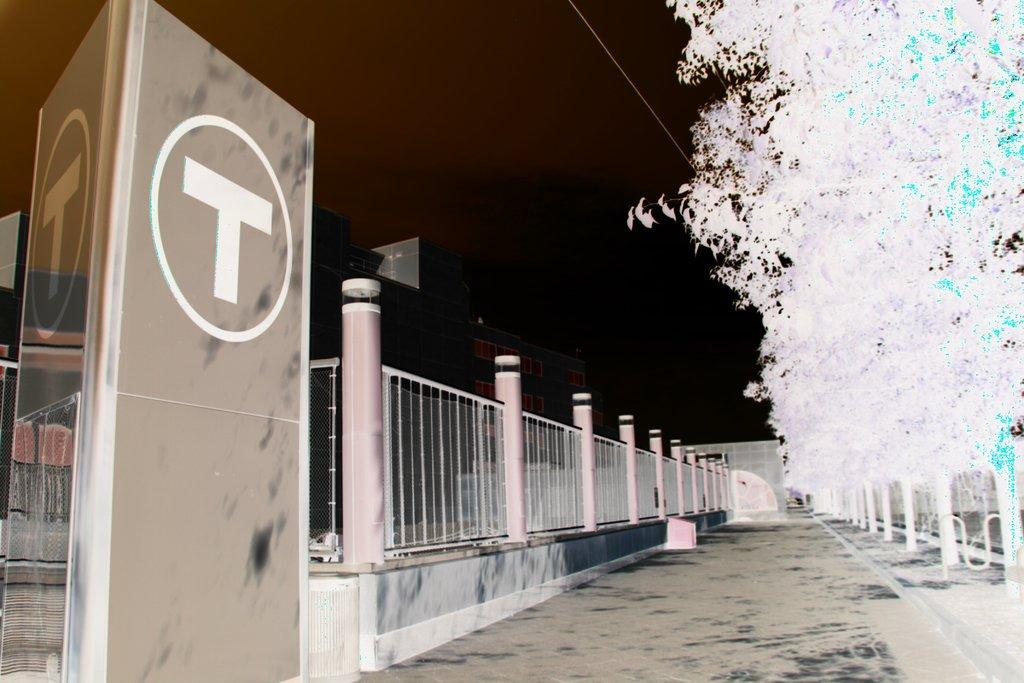What is the primary surface visible in the image? There is a floor in the image. What type of structure can be seen in the image? There is a building in the image. What are some features of the building? There are railings, poles, and hoardings visible in the image. How would you describe the lighting conditions in the image? The background of the image is dark. Is there any part of the image that is not in focus? The right side of the image is blurry. How many slaves are depicted in the image? There are no slaves present in the image. What type of land can be seen in the image? There is no land visible in the image; it is focused on a building and its features. 